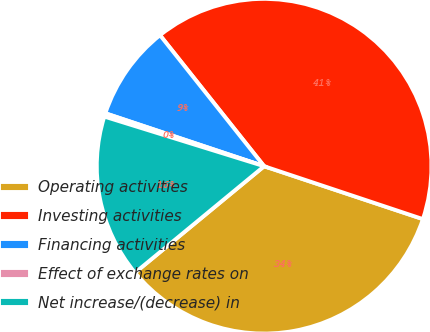Convert chart to OTSL. <chart><loc_0><loc_0><loc_500><loc_500><pie_chart><fcel>Operating activities<fcel>Investing activities<fcel>Financing activities<fcel>Effect of exchange rates on<fcel>Net increase/(decrease) in<nl><fcel>33.91%<fcel>40.81%<fcel>9.19%<fcel>0.33%<fcel>15.77%<nl></chart> 